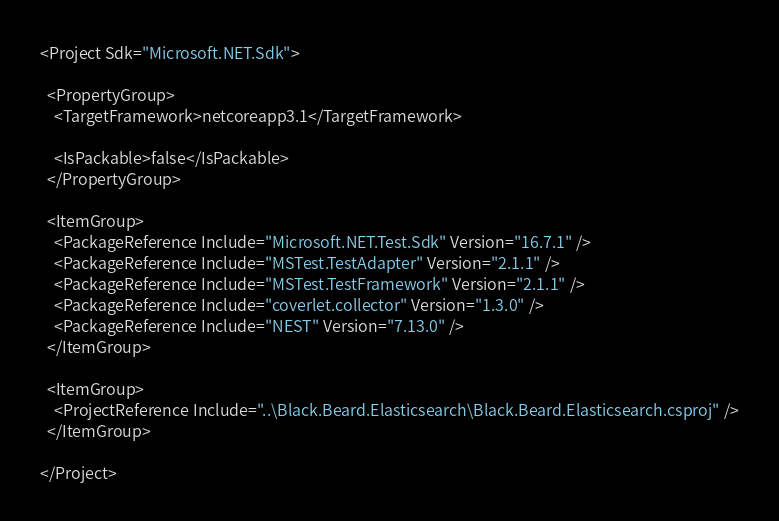<code> <loc_0><loc_0><loc_500><loc_500><_XML_><Project Sdk="Microsoft.NET.Sdk">

  <PropertyGroup>
    <TargetFramework>netcoreapp3.1</TargetFramework>

    <IsPackable>false</IsPackable>
  </PropertyGroup>

  <ItemGroup>
    <PackageReference Include="Microsoft.NET.Test.Sdk" Version="16.7.1" />
    <PackageReference Include="MSTest.TestAdapter" Version="2.1.1" />
    <PackageReference Include="MSTest.TestFramework" Version="2.1.1" />
    <PackageReference Include="coverlet.collector" Version="1.3.0" />
    <PackageReference Include="NEST" Version="7.13.0" />
  </ItemGroup>

  <ItemGroup>
    <ProjectReference Include="..\Black.Beard.Elasticsearch\Black.Beard.Elasticsearch.csproj" />
  </ItemGroup>

</Project>
</code> 